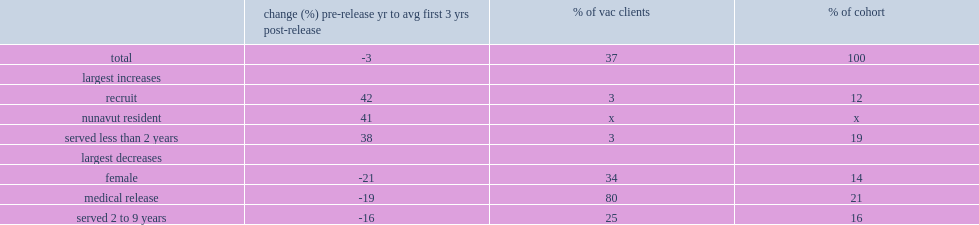What is the average percentage point of the decline in income from the pre-release year to the first three years post-release for the regular force cohort? 3. What is the percentage point of female veterans had decline in income from the pre-release year to the first three years post-release? 21. What is the percentage point of medically released veterans had decline in income from the pre-release year to the first three years post-release? 19. What is the percentage point of those who served 2 to 9 years had decline in income from the pre-release year to the first three years post-release? 16. 